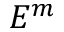Convert formula to latex. <formula><loc_0><loc_0><loc_500><loc_500>E ^ { m }</formula> 